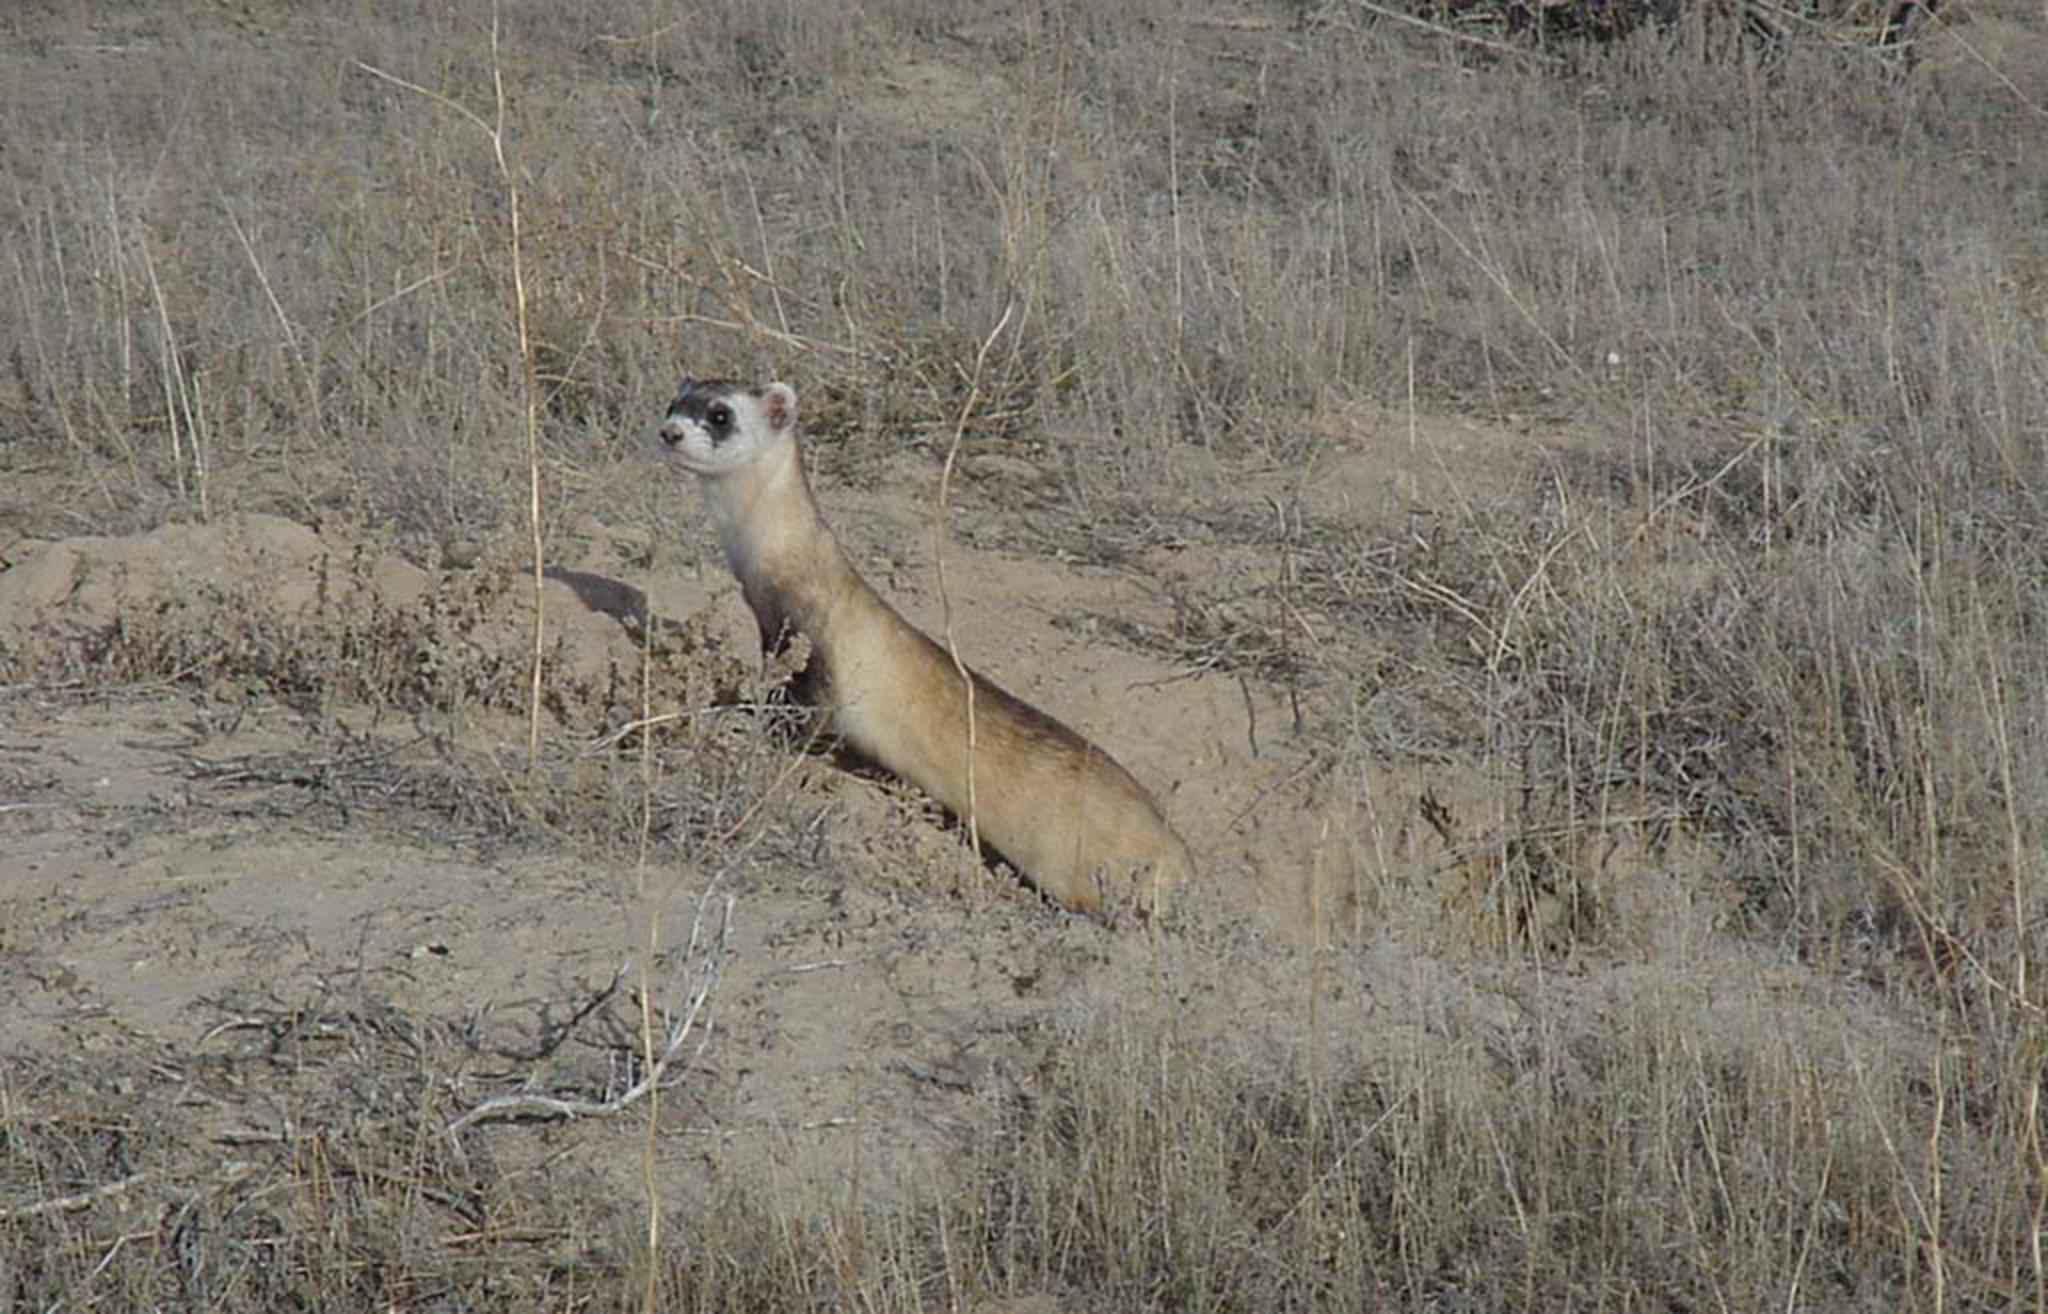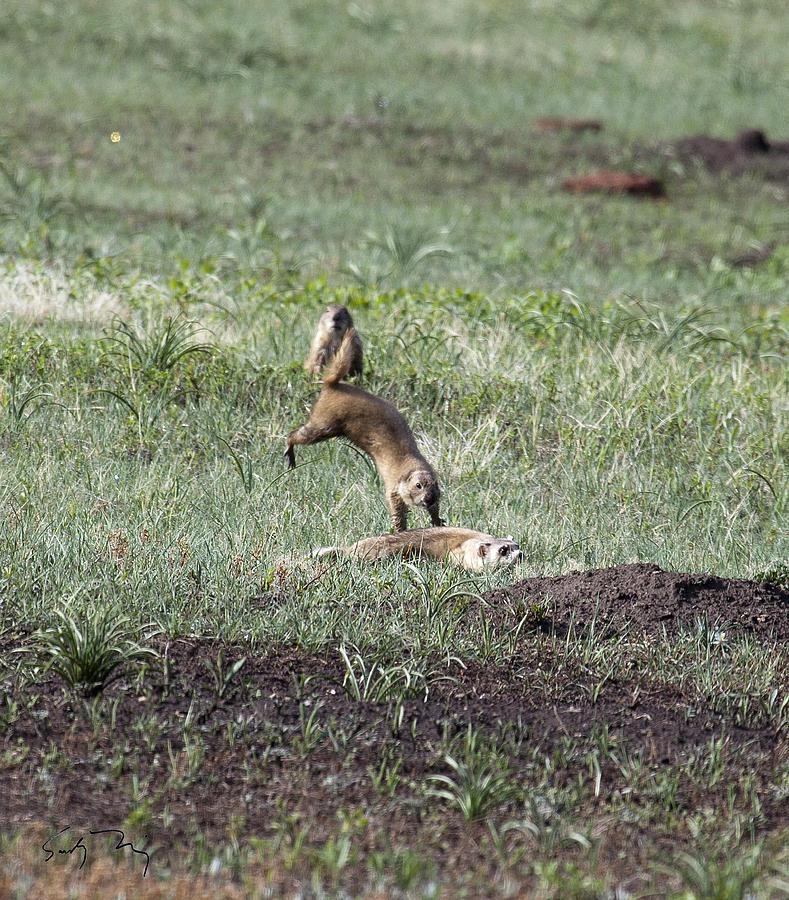The first image is the image on the left, the second image is the image on the right. Examine the images to the left and right. Is the description "There are exactly two animals in the image on the left." accurate? Answer yes or no. No. The first image is the image on the left, the second image is the image on the right. Examine the images to the left and right. Is the description "Right image shows a ferret pursuing a different breed of animal outdoors." accurate? Answer yes or no. No. 